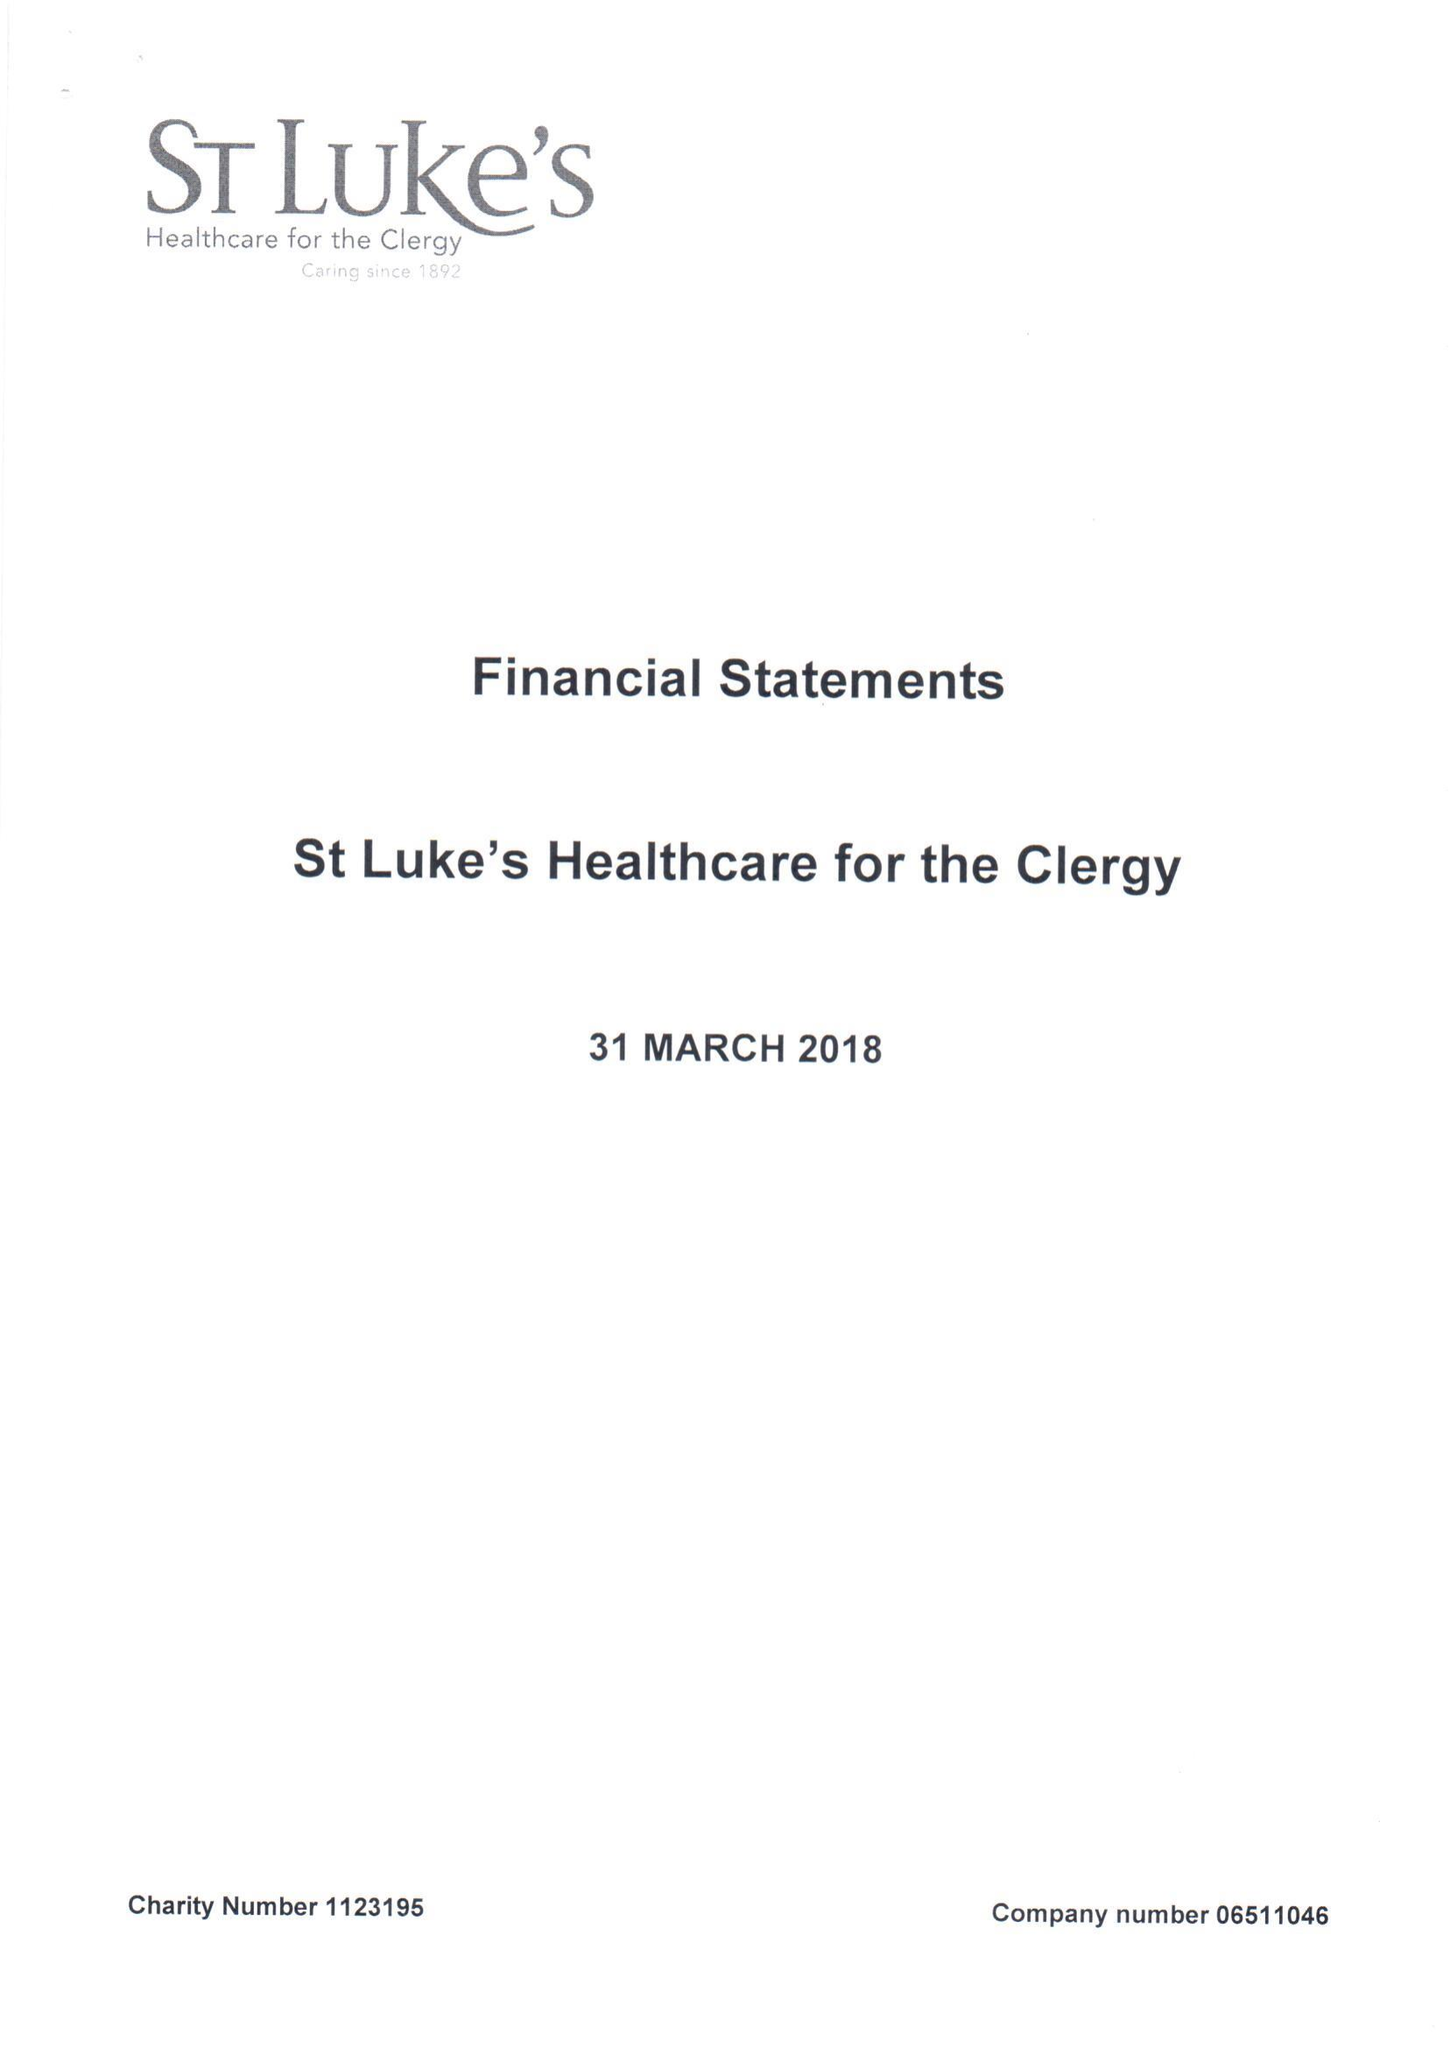What is the value for the charity_name?
Answer the question using a single word or phrase. St Luke's Healthcare For The Clergy 